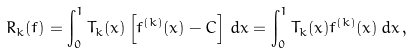<formula> <loc_0><loc_0><loc_500><loc_500>R _ { k } ( f ) = \int _ { 0 } ^ { 1 } T _ { k } ( x ) \left [ f ^ { ( k ) } ( x ) - C \right ] \, d x = \int _ { 0 } ^ { 1 } T _ { k } ( x ) f ^ { ( k ) } ( x ) \, d x \, ,</formula> 